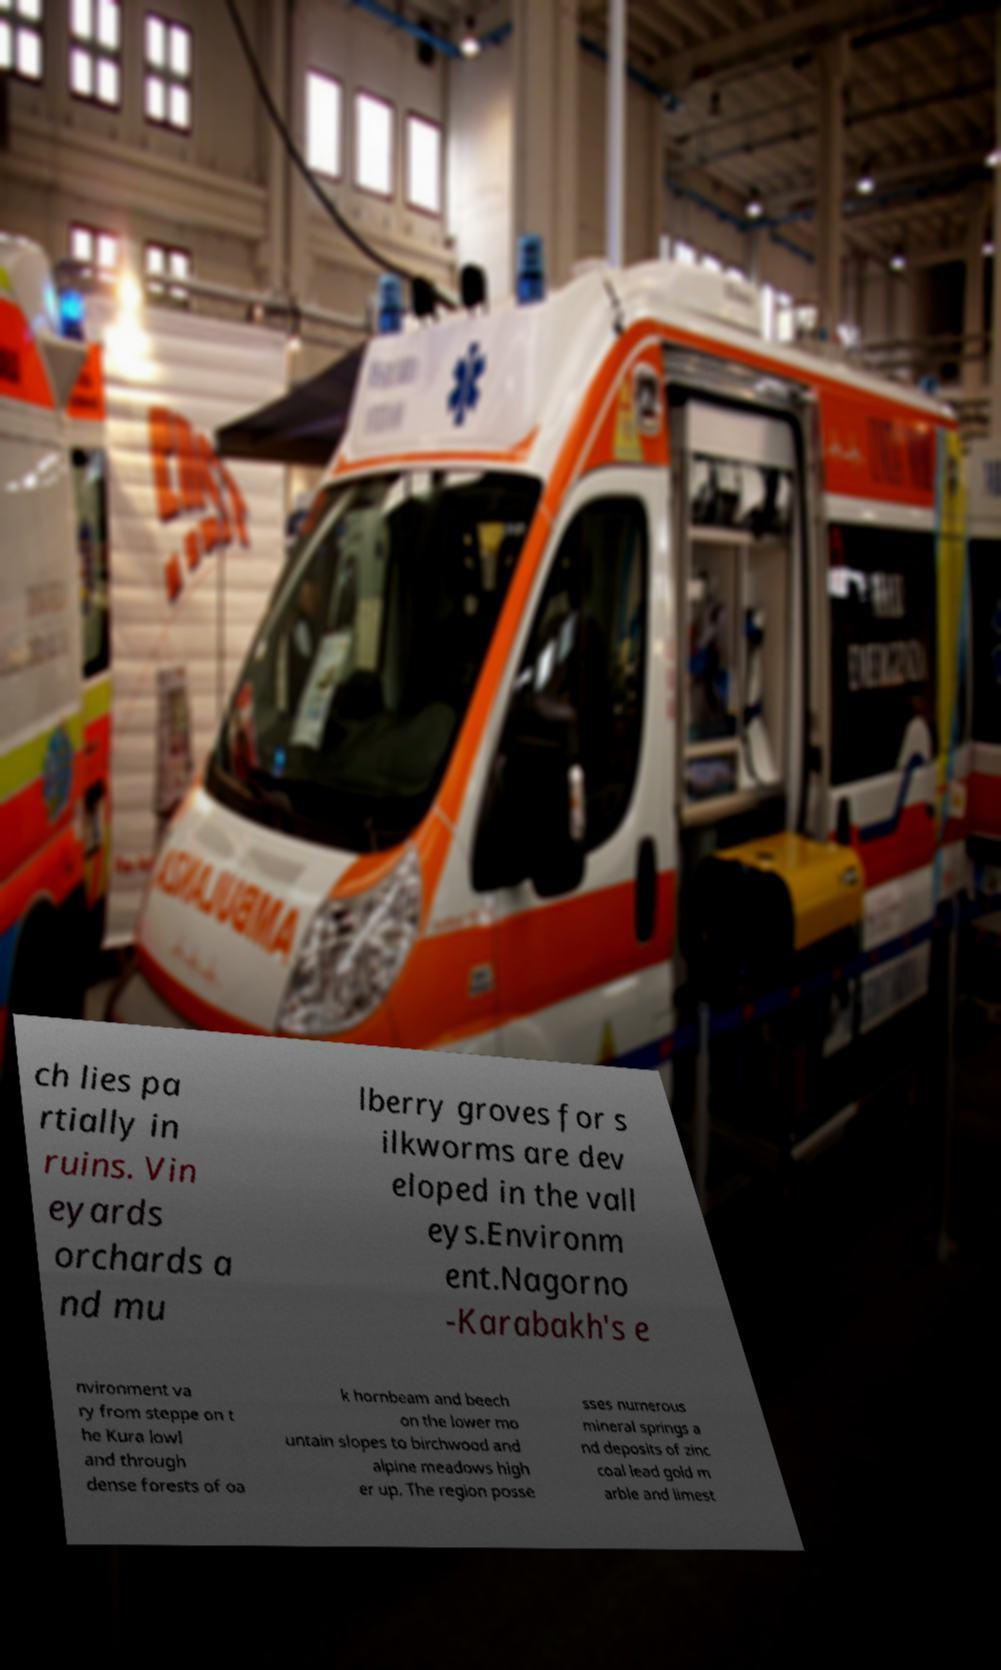Can you read and provide the text displayed in the image?This photo seems to have some interesting text. Can you extract and type it out for me? ch lies pa rtially in ruins. Vin eyards orchards a nd mu lberry groves for s ilkworms are dev eloped in the vall eys.Environm ent.Nagorno -Karabakh's e nvironment va ry from steppe on t he Kura lowl and through dense forests of oa k hornbeam and beech on the lower mo untain slopes to birchwood and alpine meadows high er up. The region posse sses numerous mineral springs a nd deposits of zinc coal lead gold m arble and limest 